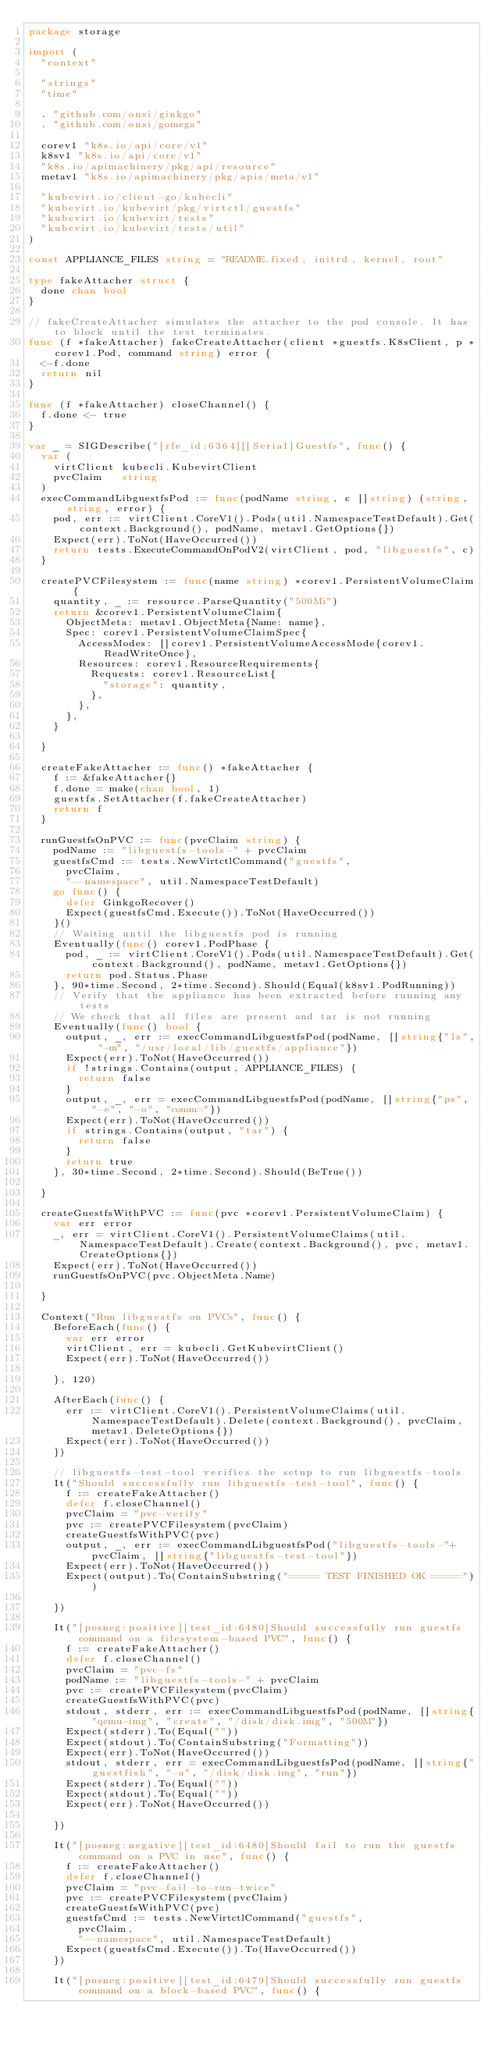<code> <loc_0><loc_0><loc_500><loc_500><_Go_>package storage

import (
	"context"

	"strings"
	"time"

	. "github.com/onsi/ginkgo"
	. "github.com/onsi/gomega"

	corev1 "k8s.io/api/core/v1"
	k8sv1 "k8s.io/api/core/v1"
	"k8s.io/apimachinery/pkg/api/resource"
	metav1 "k8s.io/apimachinery/pkg/apis/meta/v1"

	"kubevirt.io/client-go/kubecli"
	"kubevirt.io/kubevirt/pkg/virtctl/guestfs"
	"kubevirt.io/kubevirt/tests"
	"kubevirt.io/kubevirt/tests/util"
)

const APPLIANCE_FILES string = "README.fixed, initrd, kernel, root"

type fakeAttacher struct {
	done chan bool
}

// fakeCreateAttacher simulates the attacher to the pod console. It has to block until the test terminates.
func (f *fakeAttacher) fakeCreateAttacher(client *guestfs.K8sClient, p *corev1.Pod, command string) error {
	<-f.done
	return nil
}

func (f *fakeAttacher) closeChannel() {
	f.done <- true
}

var _ = SIGDescribe("[rfe_id:6364][[Serial]Guestfs", func() {
	var (
		virtClient kubecli.KubevirtClient
		pvcClaim   string
	)
	execCommandLibguestfsPod := func(podName string, c []string) (string, string, error) {
		pod, err := virtClient.CoreV1().Pods(util.NamespaceTestDefault).Get(context.Background(), podName, metav1.GetOptions{})
		Expect(err).ToNot(HaveOccurred())
		return tests.ExecuteCommandOnPodV2(virtClient, pod, "libguestfs", c)
	}

	createPVCFilesystem := func(name string) *corev1.PersistentVolumeClaim {
		quantity, _ := resource.ParseQuantity("500Mi")
		return &corev1.PersistentVolumeClaim{
			ObjectMeta: metav1.ObjectMeta{Name: name},
			Spec: corev1.PersistentVolumeClaimSpec{
				AccessModes: []corev1.PersistentVolumeAccessMode{corev1.ReadWriteOnce},
				Resources: corev1.ResourceRequirements{
					Requests: corev1.ResourceList{
						"storage": quantity,
					},
				},
			},
		}

	}

	createFakeAttacher := func() *fakeAttacher {
		f := &fakeAttacher{}
		f.done = make(chan bool, 1)
		guestfs.SetAttacher(f.fakeCreateAttacher)
		return f
	}

	runGuestfsOnPVC := func(pvcClaim string) {
		podName := "libguestfs-tools-" + pvcClaim
		guestfsCmd := tests.NewVirtctlCommand("guestfs",
			pvcClaim,
			"--namespace", util.NamespaceTestDefault)
		go func() {
			defer GinkgoRecover()
			Expect(guestfsCmd.Execute()).ToNot(HaveOccurred())
		}()
		// Waiting until the libguestfs pod is running
		Eventually(func() corev1.PodPhase {
			pod, _ := virtClient.CoreV1().Pods(util.NamespaceTestDefault).Get(context.Background(), podName, metav1.GetOptions{})
			return pod.Status.Phase
		}, 90*time.Second, 2*time.Second).Should(Equal(k8sv1.PodRunning))
		// Verify that the appliance has been extracted before running any tests
		// We check that all files are present and tar is not running
		Eventually(func() bool {
			output, _, err := execCommandLibguestfsPod(podName, []string{"ls", "-m", "/usr/local/lib/guestfs/appliance"})
			Expect(err).ToNot(HaveOccurred())
			if !strings.Contains(output, APPLIANCE_FILES) {
				return false
			}
			output, _, err = execCommandLibguestfsPod(podName, []string{"ps", "-e", "-o", "comm="})
			Expect(err).ToNot(HaveOccurred())
			if strings.Contains(output, "tar") {
				return false
			}
			return true
		}, 30*time.Second, 2*time.Second).Should(BeTrue())

	}

	createGuestfsWithPVC := func(pvc *corev1.PersistentVolumeClaim) {
		var err error
		_, err = virtClient.CoreV1().PersistentVolumeClaims(util.NamespaceTestDefault).Create(context.Background(), pvc, metav1.CreateOptions{})
		Expect(err).ToNot(HaveOccurred())
		runGuestfsOnPVC(pvc.ObjectMeta.Name)

	}

	Context("Run libguestfs on PVCs", func() {
		BeforeEach(func() {
			var err error
			virtClient, err = kubecli.GetKubevirtClient()
			Expect(err).ToNot(HaveOccurred())

		}, 120)

		AfterEach(func() {
			err := virtClient.CoreV1().PersistentVolumeClaims(util.NamespaceTestDefault).Delete(context.Background(), pvcClaim, metav1.DeleteOptions{})
			Expect(err).ToNot(HaveOccurred())
		})

		// libguestfs-test-tool verifies the setup to run libguestfs-tools
		It("Should successfully run libguestfs-test-tool", func() {
			f := createFakeAttacher()
			defer f.closeChannel()
			pvcClaim = "pvc-verify"
			pvc := createPVCFilesystem(pvcClaim)
			createGuestfsWithPVC(pvc)
			output, _, err := execCommandLibguestfsPod("libguestfs-tools-"+pvcClaim, []string{"libguestfs-test-tool"})
			Expect(err).ToNot(HaveOccurred())
			Expect(output).To(ContainSubstring("===== TEST FINISHED OK ====="))

		})

		It("[posneg:positive][test_id:6480]Should successfully run guestfs command on a filesystem-based PVC", func() {
			f := createFakeAttacher()
			defer f.closeChannel()
			pvcClaim = "pvc-fs"
			podName := "libguestfs-tools-" + pvcClaim
			pvc := createPVCFilesystem(pvcClaim)
			createGuestfsWithPVC(pvc)
			stdout, stderr, err := execCommandLibguestfsPod(podName, []string{"qemu-img", "create", "/disk/disk.img", "500M"})
			Expect(stderr).To(Equal(""))
			Expect(stdout).To(ContainSubstring("Formatting"))
			Expect(err).ToNot(HaveOccurred())
			stdout, stderr, err = execCommandLibguestfsPod(podName, []string{"guestfish", "-a", "/disk/disk.img", "run"})
			Expect(stderr).To(Equal(""))
			Expect(stdout).To(Equal(""))
			Expect(err).ToNot(HaveOccurred())

		})

		It("[posneg:negative][test_id:6480]Should fail to run the guestfs command on a PVC in use", func() {
			f := createFakeAttacher()
			defer f.closeChannel()
			pvcClaim = "pvc-fail-to-run-twice"
			pvc := createPVCFilesystem(pvcClaim)
			createGuestfsWithPVC(pvc)
			guestfsCmd := tests.NewVirtctlCommand("guestfs",
				pvcClaim,
				"--namespace", util.NamespaceTestDefault)
			Expect(guestfsCmd.Execute()).To(HaveOccurred())
		})

		It("[posneg:positive][test_id:6479]Should successfully run guestfs command on a block-based PVC", func() {</code> 